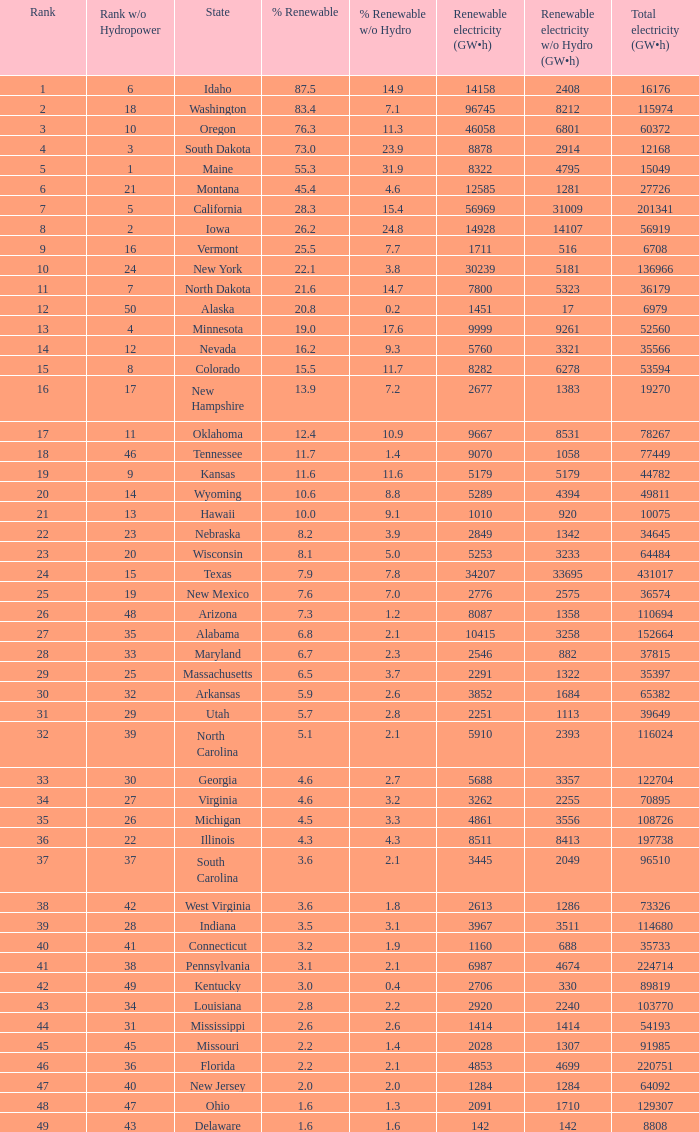When renewable electricity is 5760 (gw×h) what is the minimum amount of renewable elecrrixity without hydrogen power? 3321.0. 